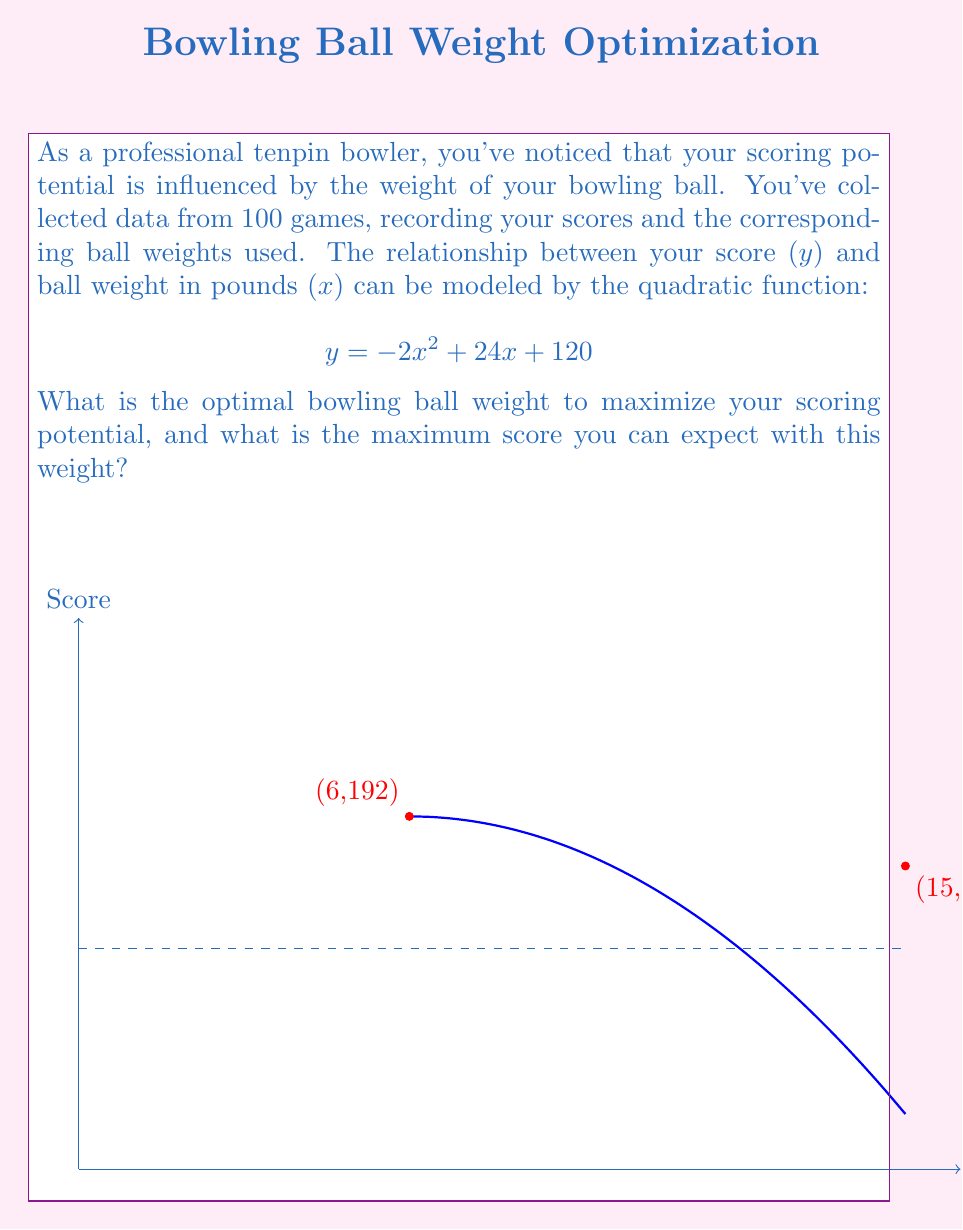Teach me how to tackle this problem. To find the optimal bowling ball weight, we need to maximize the quadratic function:

$$y = -2x^2 + 24x + 120$$

1. The maximum of a quadratic function occurs at the vertex of the parabola. For a quadratic function in the form $f(x) = ax^2 + bx + c$, the x-coordinate of the vertex is given by $x = -\frac{b}{2a}$.

2. In our case, $a = -2$, $b = 24$, and $c = 120$. Let's calculate the x-coordinate of the vertex:

   $$x = -\frac{24}{2(-2)} = -\frac{24}{-4} = 6$$

3. Therefore, the optimal bowling ball weight is 6 pounds.

4. To find the maximum score, we substitute $x = 6$ into the original function:

   $$y = -2(6)^2 + 24(6) + 120$$
   $$y = -2(36) + 144 + 120$$
   $$y = -72 + 144 + 120$$
   $$y = 192$$

Thus, the maximum score you can expect with the optimal ball weight is 192.
Answer: Optimal weight: 6 pounds; Maximum score: 192 